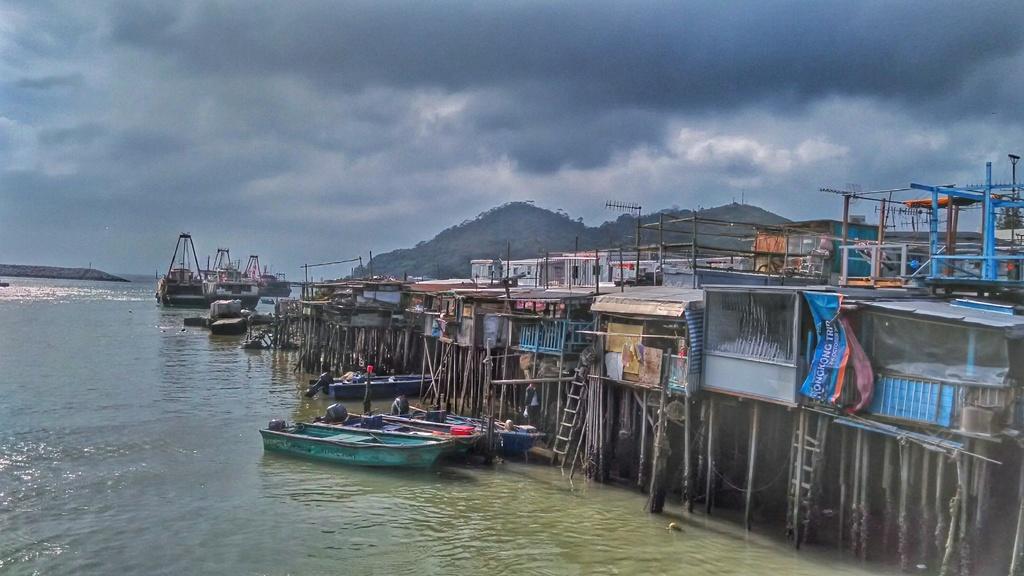How would you summarize this image in a sentence or two? In this image I can see water, boats, wooden sticks, ladders, stores, banners, mountains, cloudy sky and objects. 